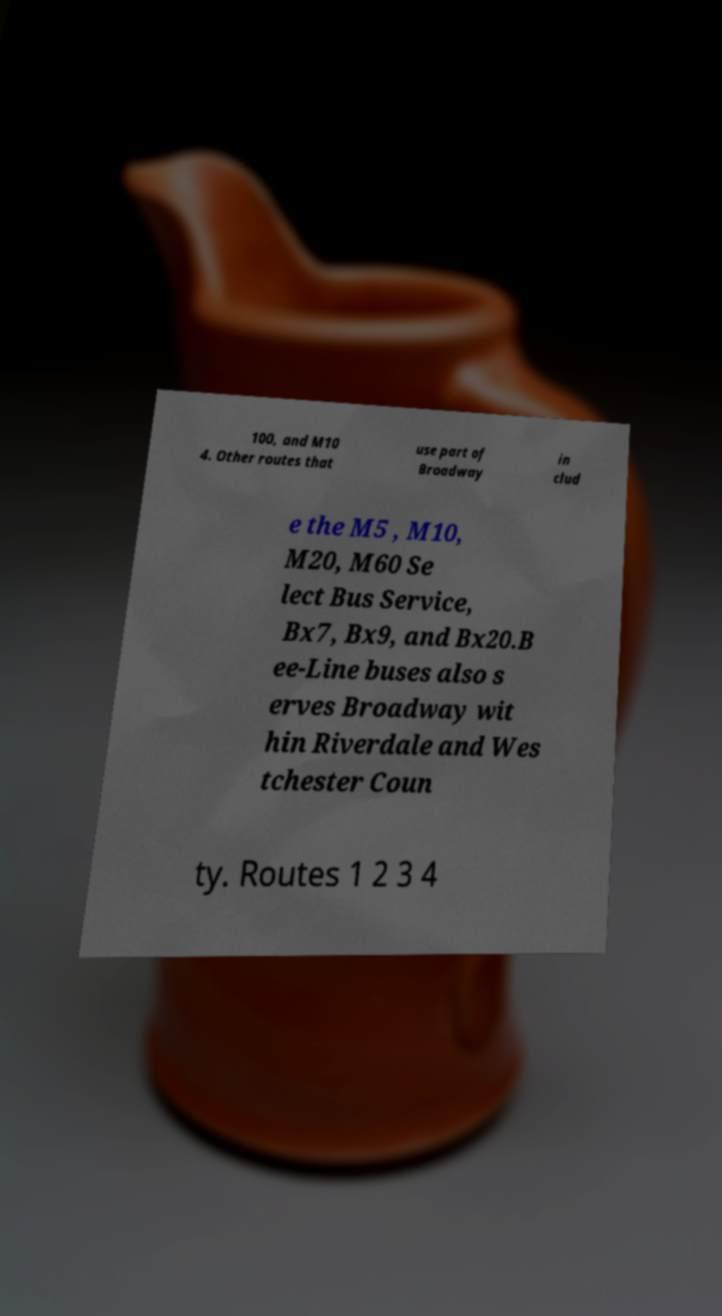Please identify and transcribe the text found in this image. 100, and M10 4. Other routes that use part of Broadway in clud e the M5 , M10, M20, M60 Se lect Bus Service, Bx7, Bx9, and Bx20.B ee-Line buses also s erves Broadway wit hin Riverdale and Wes tchester Coun ty. Routes 1 2 3 4 